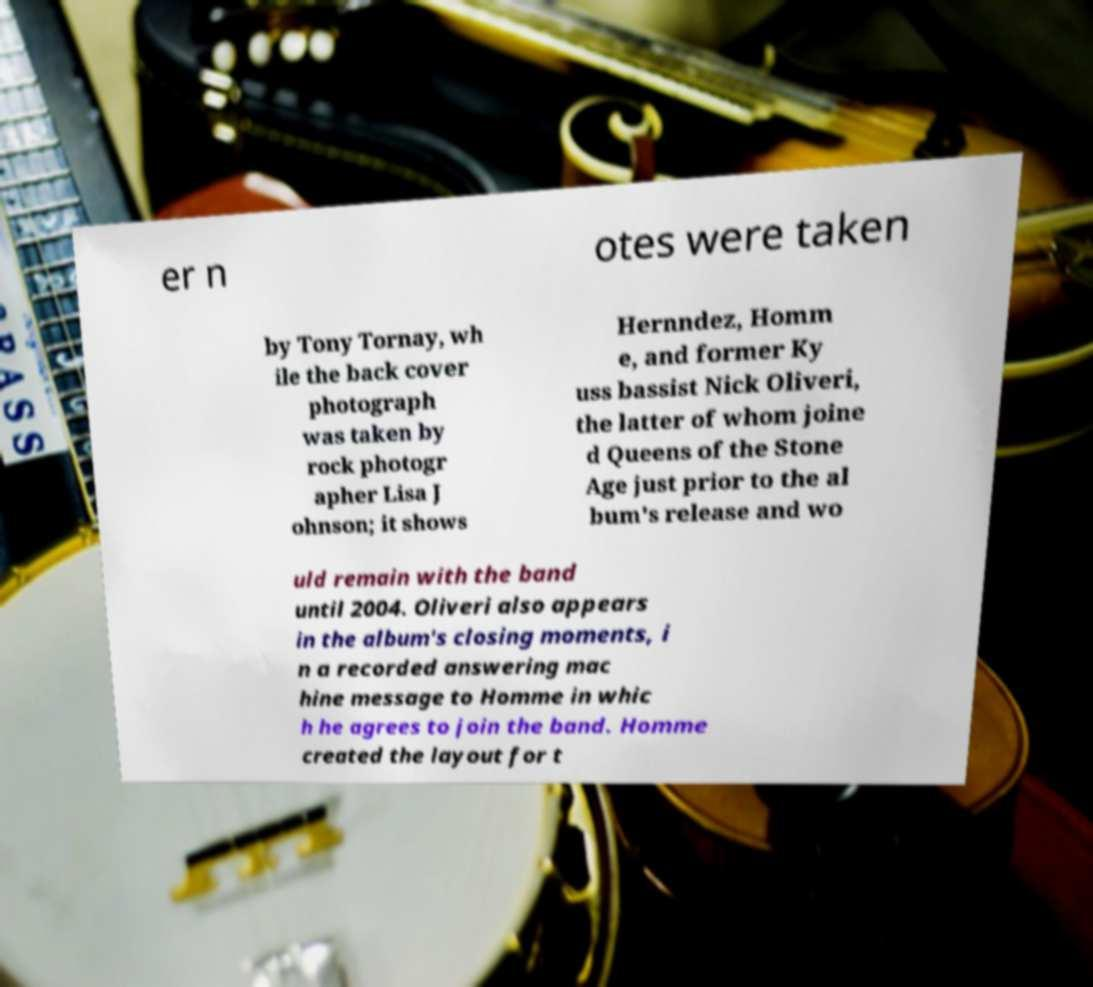There's text embedded in this image that I need extracted. Can you transcribe it verbatim? er n otes were taken by Tony Tornay, wh ile the back cover photograph was taken by rock photogr apher Lisa J ohnson; it shows Hernndez, Homm e, and former Ky uss bassist Nick Oliveri, the latter of whom joine d Queens of the Stone Age just prior to the al bum's release and wo uld remain with the band until 2004. Oliveri also appears in the album's closing moments, i n a recorded answering mac hine message to Homme in whic h he agrees to join the band. Homme created the layout for t 